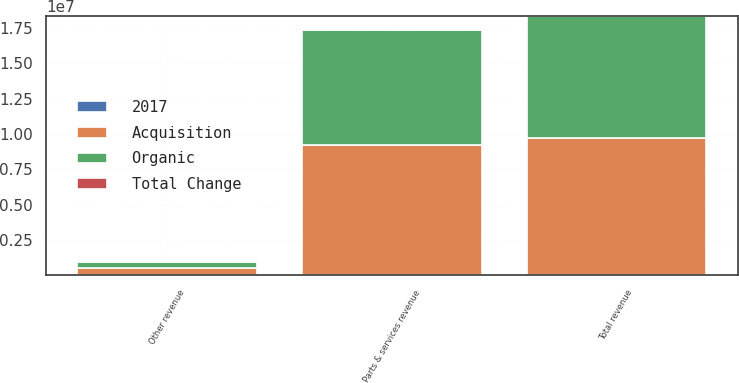<chart> <loc_0><loc_0><loc_500><loc_500><stacked_bar_chart><ecel><fcel>Parts & services revenue<fcel>Other revenue<fcel>Total revenue<nl><fcel>Acquisition<fcel>9.20863e+06<fcel>528275<fcel>9.73691e+06<nl><fcel>Organic<fcel>8.14464e+06<fcel>439386<fcel>8.58403e+06<nl><fcel>2017<fcel>4.1<fcel>19.6<fcel>4.9<nl><fcel>Total Change<fcel>9.1<fcel>0.7<fcel>8.7<nl></chart> 